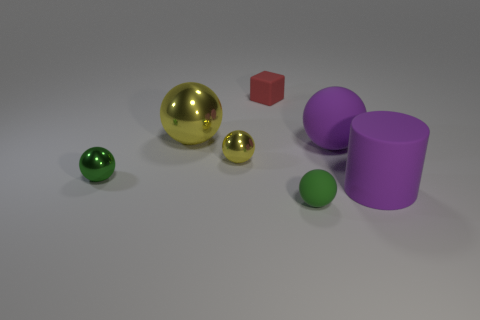Are any yellow metallic objects visible?
Keep it short and to the point. Yes. What size is the matte object that is both behind the big cylinder and in front of the large shiny thing?
Provide a short and direct response. Large. Are there more things in front of the tiny red rubber block than tiny green objects that are left of the large cylinder?
Make the answer very short. Yes. The rubber sphere that is the same color as the large matte cylinder is what size?
Provide a succinct answer. Large. What color is the tiny rubber sphere?
Offer a very short reply. Green. What is the color of the big thing that is both behind the rubber cylinder and right of the big yellow shiny thing?
Keep it short and to the point. Purple. The tiny object on the left side of the yellow metallic thing in front of the large object that is to the left of the big purple ball is what color?
Keep it short and to the point. Green. The matte ball that is the same size as the red block is what color?
Your answer should be very brief. Green. What is the shape of the small rubber object that is on the right side of the small rubber object that is behind the small green object behind the green matte sphere?
Offer a terse response. Sphere. There is a tiny object that is the same color as the small matte ball; what is its shape?
Provide a short and direct response. Sphere. 